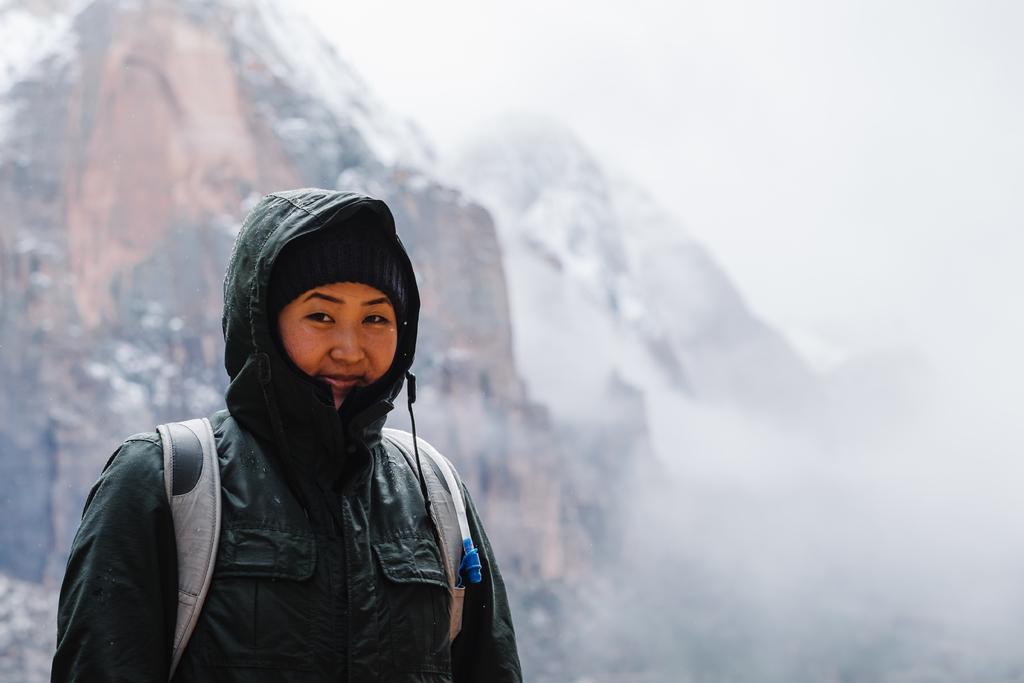Please provide a concise description of this image. In the foreground of the picture there is a woman wearing a jacket and a backpack. In the background there are mountains and it is fog. 